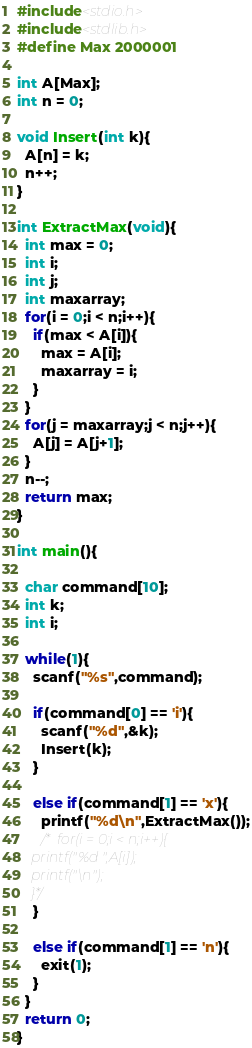Convert code to text. <code><loc_0><loc_0><loc_500><loc_500><_C_>#include<stdio.h>
#include<stdlib.h>
#define Max 2000001

int A[Max];
int n = 0;

void Insert(int k){
  A[n] = k;
  n++;
}

int ExtractMax(void){
  int max = 0;
  int i;
  int j;
  int maxarray;
  for(i = 0;i < n;i++){
    if(max < A[i]){
      max = A[i];
      maxarray = i;
    }
  }
  for(j = maxarray;j < n;j++){
    A[j] = A[j+1];
  }
  n--;
  return max;
}

int main(){

  char command[10];
  int k;
  int i;

  while(1){
    scanf("%s",command);

    if(command[0] == 'i'){
      scanf("%d",&k);
      Insert(k);
    }

    else if(command[1] == 'x'){
      printf("%d\n",ExtractMax());
      /*  for(i = 0;i < n;i++){
	printf("%d ",A[i]);
	printf("\n");
	}*/
    }

    else if(command[1] == 'n'){
      exit(1);
    }
  }
  return 0;
}</code> 